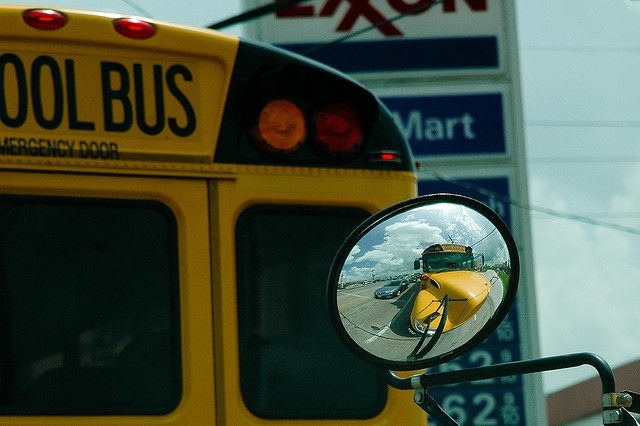Describe the objects in this image and their specific colors. I can see bus in black, lightblue, olive, maroon, and teal tones and car in lightblue, black, and teal tones in this image. 